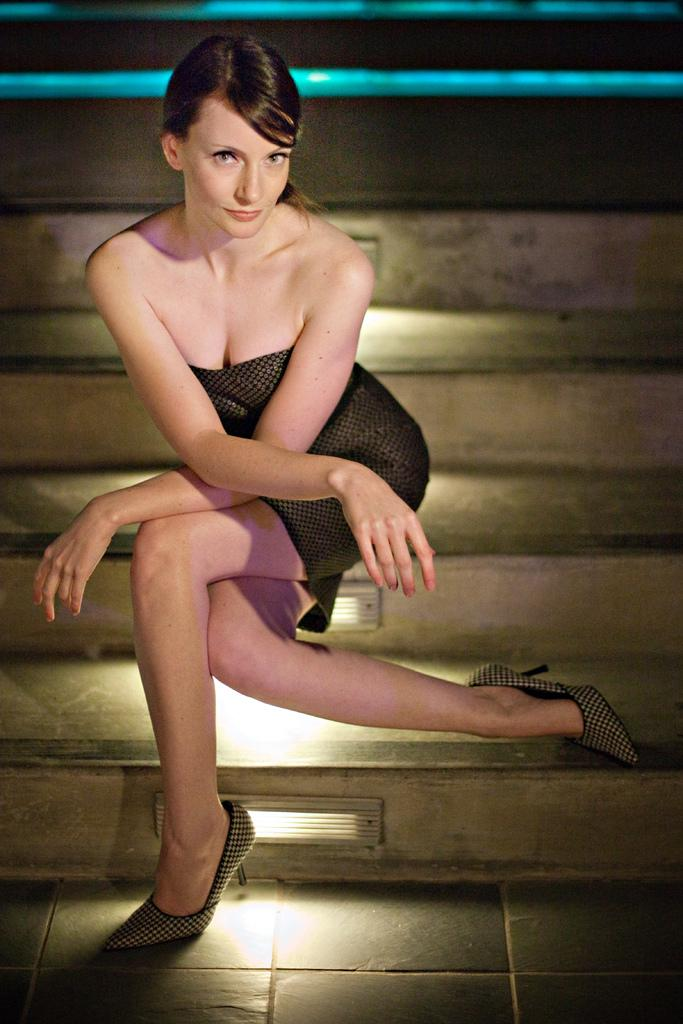Who is the main subject in the image? There is a lady in the image. What is the lady doing in the image? The lady is sitting on the steps. What type of footwear is the lady wearing? The lady is wearing heels. Can you describe the lighting in the image? There are lights on the steps. How many pigs are visible in the image? There are no pigs present in the image. What type of yarn is the lady using to knit in the image? The lady is not knitting in the image, and there is no yarn present. 